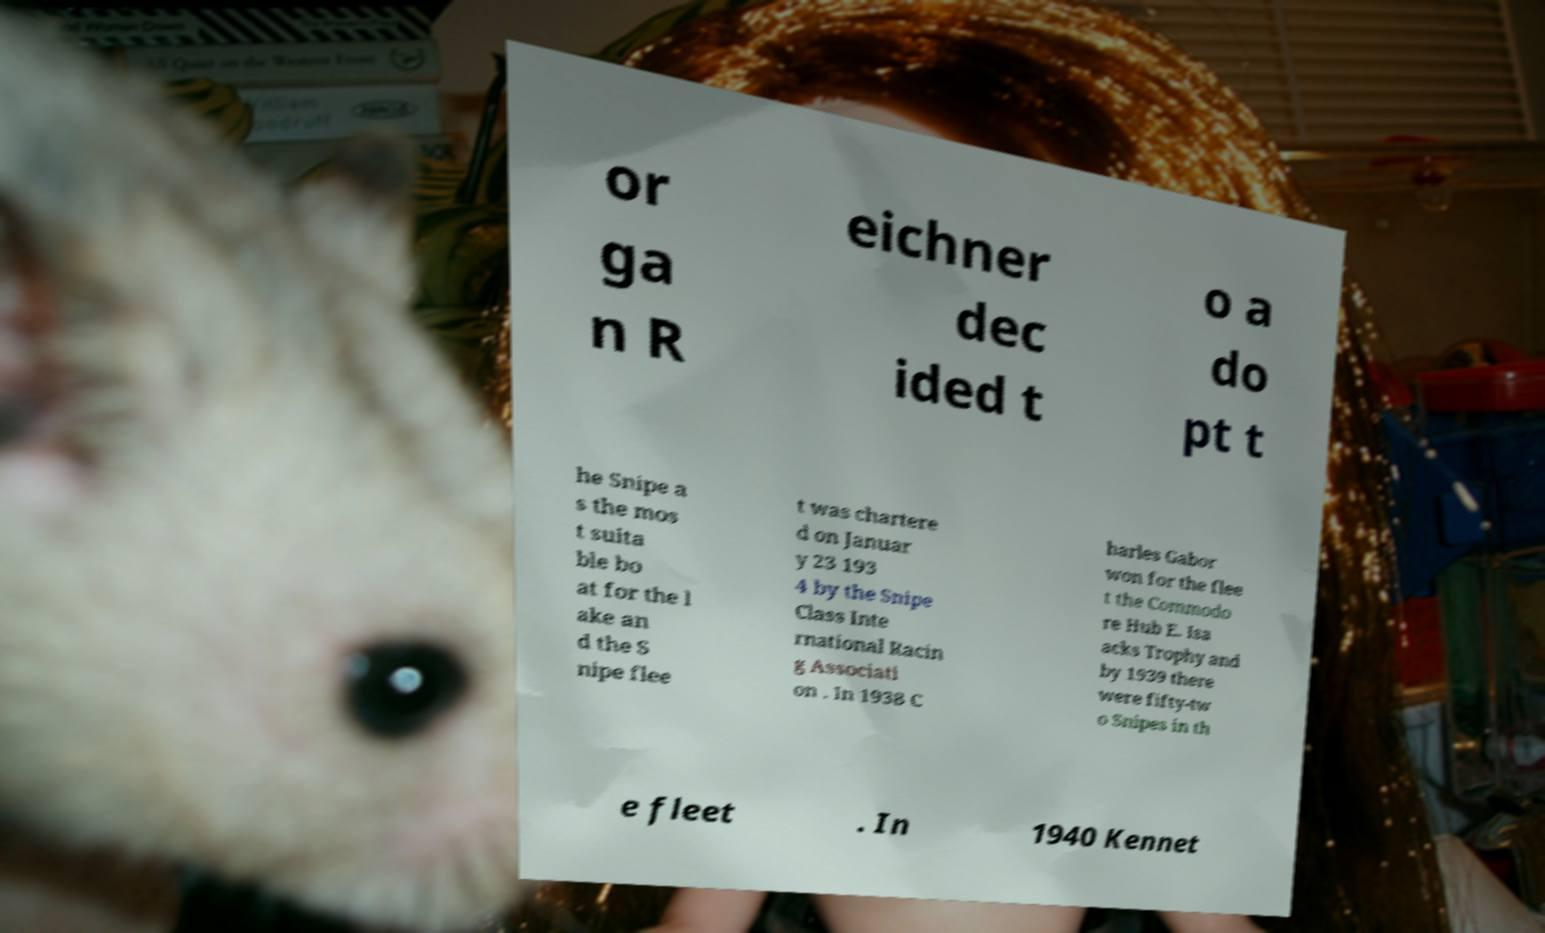I need the written content from this picture converted into text. Can you do that? or ga n R eichner dec ided t o a do pt t he Snipe a s the mos t suita ble bo at for the l ake an d the S nipe flee t was chartere d on Januar y 23 193 4 by the Snipe Class Inte rnational Racin g Associati on . In 1938 C harles Gabor won for the flee t the Commodo re Hub E. Isa acks Trophy and by 1939 there were fifty-tw o Snipes in th e fleet . In 1940 Kennet 